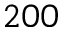<formula> <loc_0><loc_0><loc_500><loc_500>2 0 0</formula> 